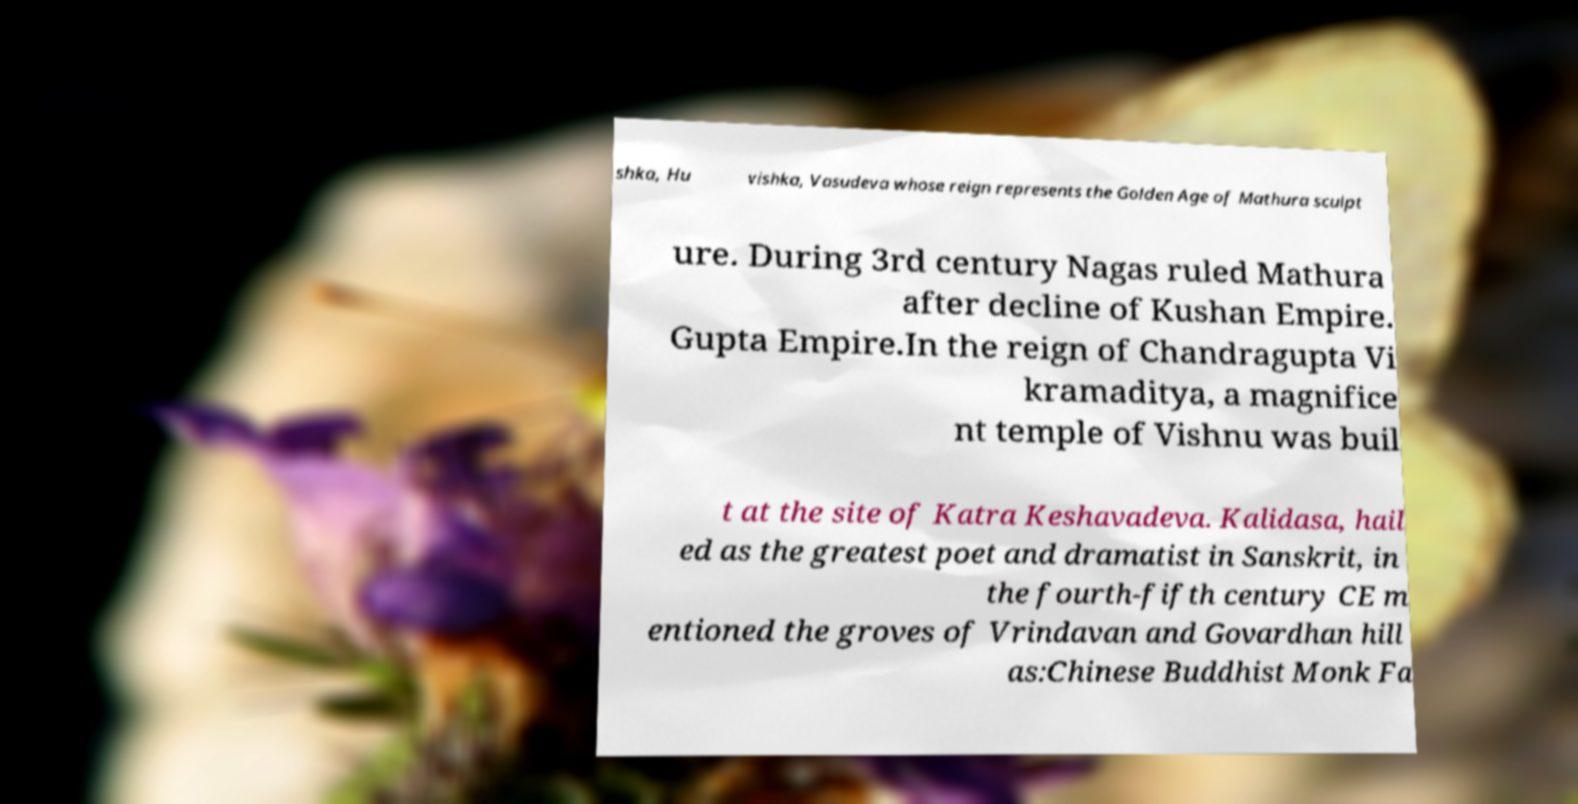Could you extract and type out the text from this image? shka, Hu vishka, Vasudeva whose reign represents the Golden Age of Mathura sculpt ure. During 3rd century Nagas ruled Mathura after decline of Kushan Empire. Gupta Empire.In the reign of Chandragupta Vi kramaditya, a magnifice nt temple of Vishnu was buil t at the site of Katra Keshavadeva. Kalidasa, hail ed as the greatest poet and dramatist in Sanskrit, in the fourth-fifth century CE m entioned the groves of Vrindavan and Govardhan hill as:Chinese Buddhist Monk Fa 